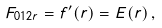<formula> <loc_0><loc_0><loc_500><loc_500>F _ { 0 1 2 r } = f ^ { \prime } ( r ) = E ( r ) \, ,</formula> 